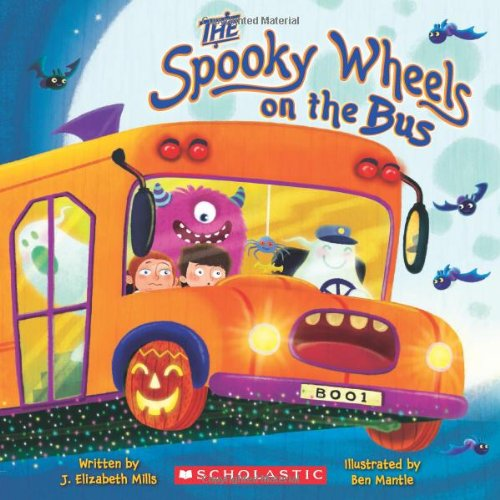Is this an art related book? No, this book is not primarily about art. It's a children's book that focuses on providing a fun, thematic story for kids, incorporating colorful illustrations to enhance the storytelling. 